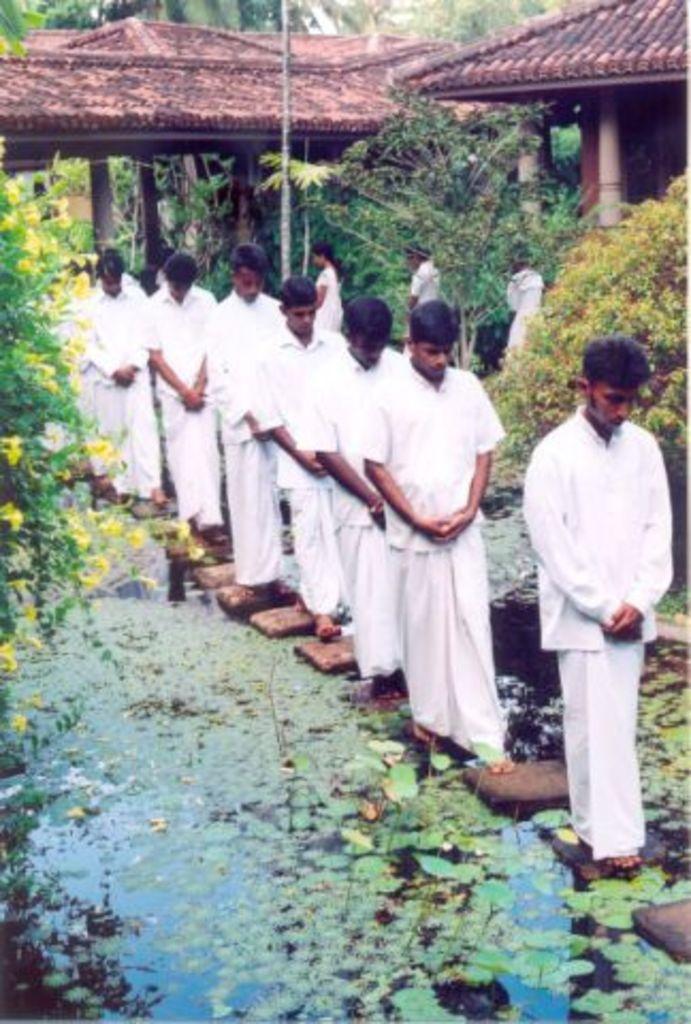Can you describe this image briefly? In this image, there are a few people. We can see some water with objects and leaves. There are a few plants and trees. We can also see a pole. We can see some houses and pillars. 